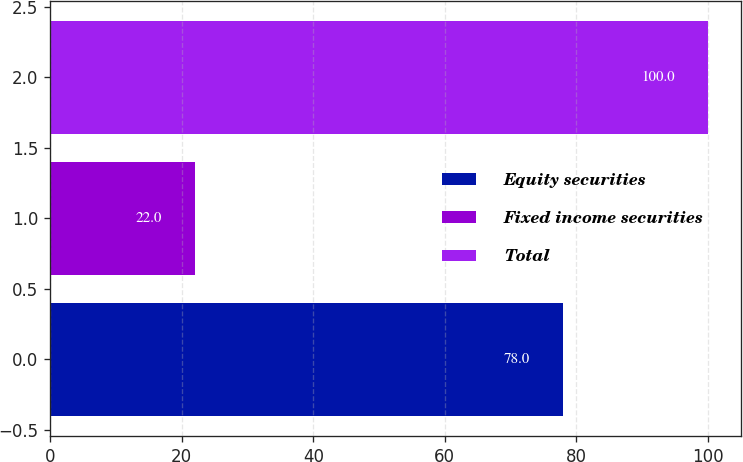Convert chart. <chart><loc_0><loc_0><loc_500><loc_500><bar_chart><fcel>Equity securities<fcel>Fixed income securities<fcel>Total<nl><fcel>78<fcel>22<fcel>100<nl></chart> 